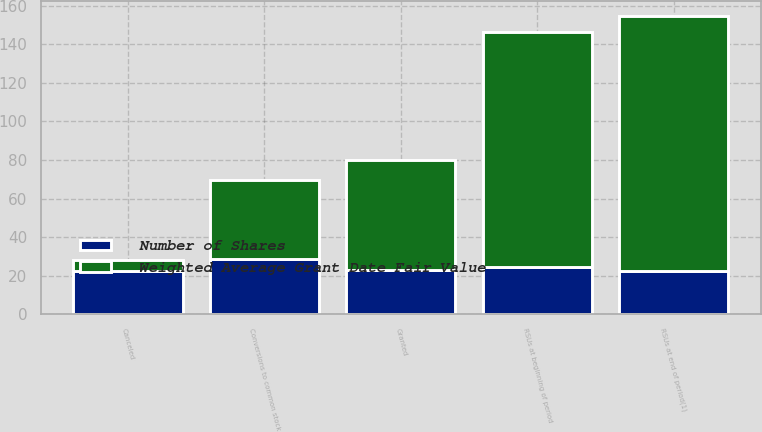Convert chart. <chart><loc_0><loc_0><loc_500><loc_500><stacked_bar_chart><ecel><fcel>RSUs at beginning of period<fcel>Granted<fcel>Conversions to common stock<fcel>Canceled<fcel>RSUs at end of period(1)<nl><fcel>Weighted Average Grant Date Fair Value<fcel>122<fcel>57<fcel>41<fcel>6<fcel>132<nl><fcel>Number of Shares<fcel>24.29<fcel>22.72<fcel>28.51<fcel>22.21<fcel>22.41<nl></chart> 